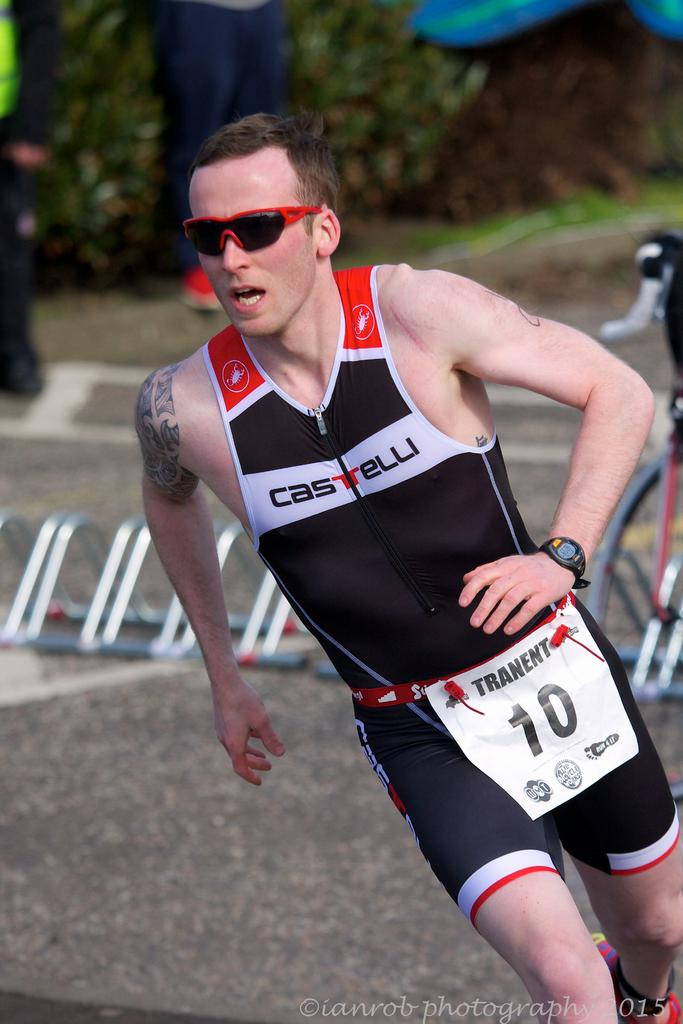Provide a one-sentence caption for the provided image. A man wearing a Castelli track suit runs down the road. 